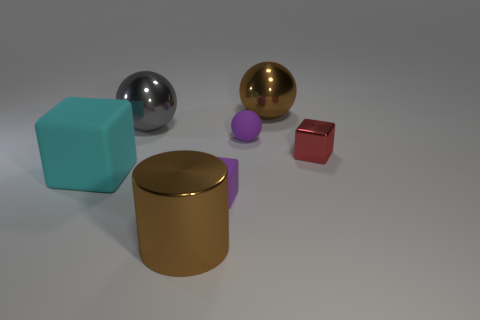Imagine these objects are part of a study on how colors affect emotions. What do you think the study might find? If these objects were part of a study on the emotional impact of colors, the study might find that the soft blue and purple hues evoke feelings of calmness and serenity, while the metallic sheen of the silver and gold could convey a sense of luxury or technological sophistication. The red object, although smaller, might stand out due to its vibrant color, potentially stirring feelings of energy or excitement. 